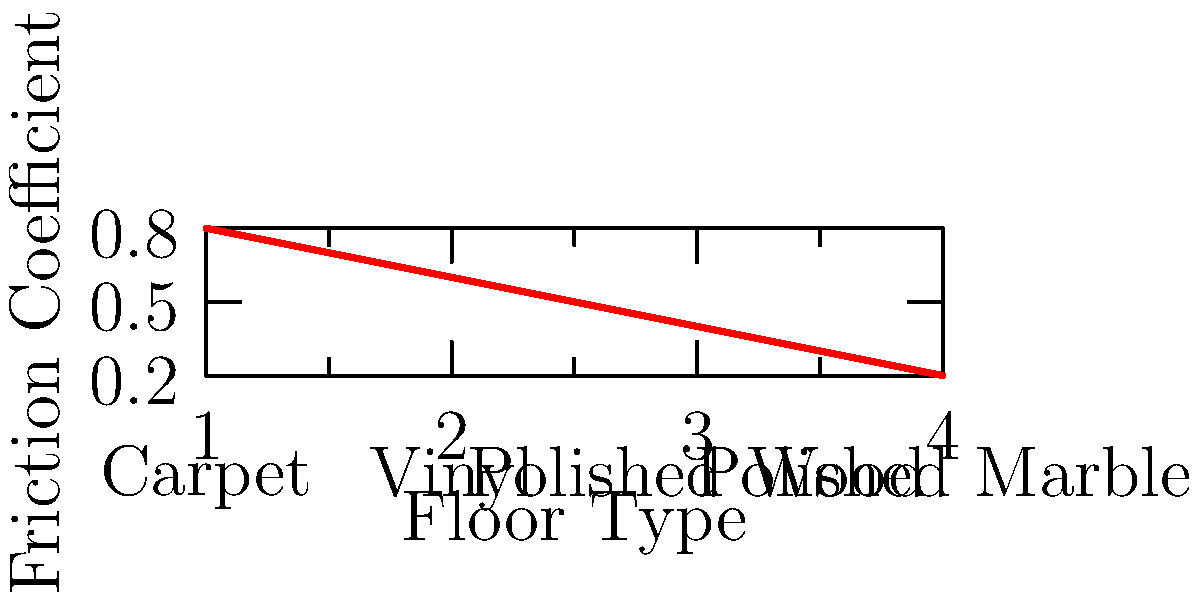As a trade show organizer, you're considering different flooring materials for your next event. The graph shows the friction coefficients of various flooring materials commonly used in convention centers. If a booth weighing 1000 N needs to be moved across the floor, what would be the minimum force required to overcome static friction on a polished marble surface? To solve this problem, we'll follow these steps:

1. Identify the friction coefficient for polished marble from the graph.
2. Recall the formula for static friction force.
3. Calculate the minimum force required to overcome static friction.

Step 1: From the graph, we can see that polished marble (rightmost data point) has a friction coefficient of approximately 0.2.

Step 2: The formula for static friction force is:

$$ F_f = \mu_s \cdot N $$

Where:
$F_f$ = friction force
$\mu_s$ = coefficient of static friction
$N$ = normal force (equal to the weight of the object on a horizontal surface)

Step 3: Calculate the minimum force required:

$N = 1000$ N (given weight of the booth)
$\mu_s = 0.2$ (from the graph)

$$ F_f = 0.2 \cdot 1000 \text{ N} = 200 \text{ N} $$

Therefore, the minimum force required to overcome static friction and start moving the booth on polished marble is 200 N.
Answer: 200 N 